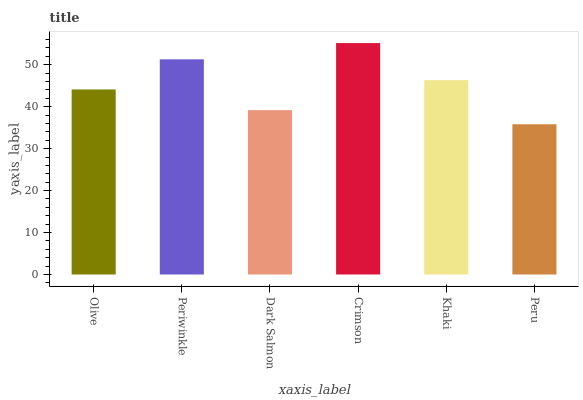Is Peru the minimum?
Answer yes or no. Yes. Is Crimson the maximum?
Answer yes or no. Yes. Is Periwinkle the minimum?
Answer yes or no. No. Is Periwinkle the maximum?
Answer yes or no. No. Is Periwinkle greater than Olive?
Answer yes or no. Yes. Is Olive less than Periwinkle?
Answer yes or no. Yes. Is Olive greater than Periwinkle?
Answer yes or no. No. Is Periwinkle less than Olive?
Answer yes or no. No. Is Khaki the high median?
Answer yes or no. Yes. Is Olive the low median?
Answer yes or no. Yes. Is Peru the high median?
Answer yes or no. No. Is Khaki the low median?
Answer yes or no. No. 